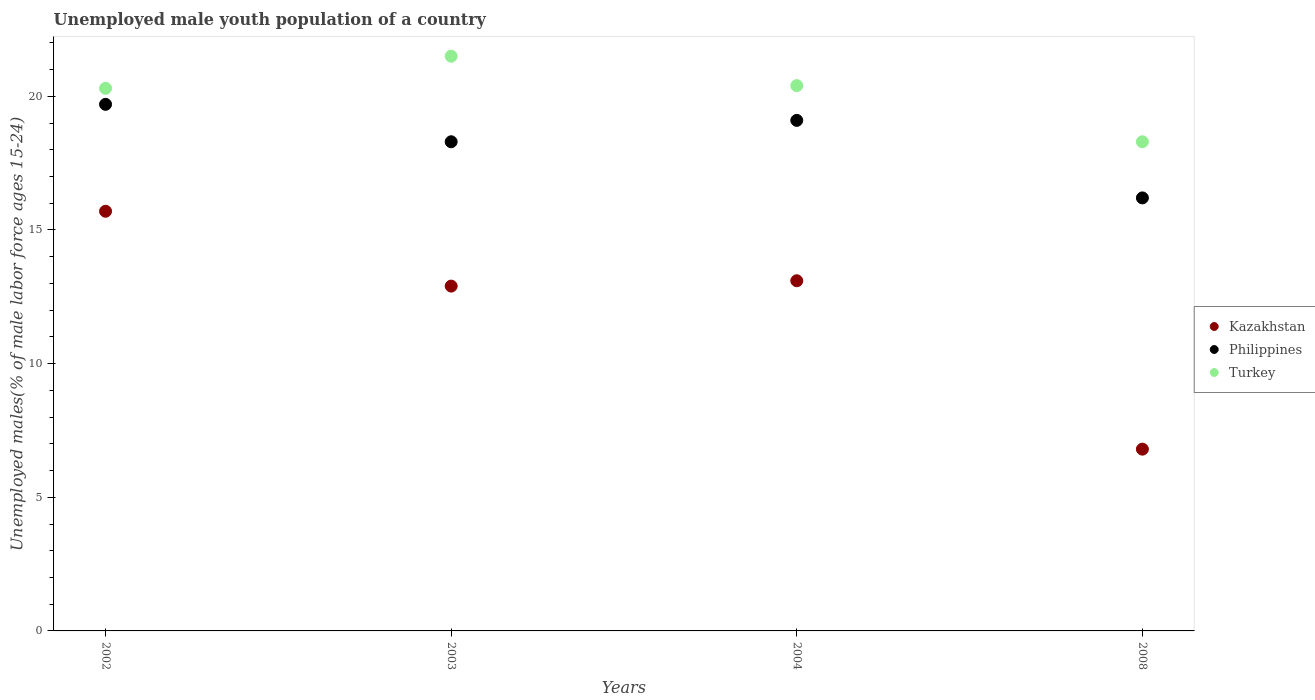What is the percentage of unemployed male youth population in Philippines in 2002?
Keep it short and to the point. 19.7. Across all years, what is the maximum percentage of unemployed male youth population in Kazakhstan?
Offer a terse response. 15.7. Across all years, what is the minimum percentage of unemployed male youth population in Philippines?
Ensure brevity in your answer.  16.2. In which year was the percentage of unemployed male youth population in Philippines minimum?
Offer a very short reply. 2008. What is the total percentage of unemployed male youth population in Turkey in the graph?
Ensure brevity in your answer.  80.5. What is the difference between the percentage of unemployed male youth population in Turkey in 2003 and that in 2008?
Provide a succinct answer. 3.2. What is the difference between the percentage of unemployed male youth population in Turkey in 2004 and the percentage of unemployed male youth population in Kazakhstan in 2003?
Give a very brief answer. 7.5. What is the average percentage of unemployed male youth population in Turkey per year?
Ensure brevity in your answer.  20.12. In the year 2008, what is the difference between the percentage of unemployed male youth population in Turkey and percentage of unemployed male youth population in Philippines?
Provide a short and direct response. 2.1. In how many years, is the percentage of unemployed male youth population in Philippines greater than 14 %?
Provide a succinct answer. 4. What is the ratio of the percentage of unemployed male youth population in Turkey in 2003 to that in 2008?
Give a very brief answer. 1.17. What is the difference between the highest and the second highest percentage of unemployed male youth population in Philippines?
Your answer should be compact. 0.6. What is the difference between the highest and the lowest percentage of unemployed male youth population in Turkey?
Make the answer very short. 3.2. In how many years, is the percentage of unemployed male youth population in Philippines greater than the average percentage of unemployed male youth population in Philippines taken over all years?
Your answer should be compact. 2. Is the sum of the percentage of unemployed male youth population in Philippines in 2002 and 2003 greater than the maximum percentage of unemployed male youth population in Kazakhstan across all years?
Provide a succinct answer. Yes. Does the percentage of unemployed male youth population in Philippines monotonically increase over the years?
Provide a succinct answer. No. Is the percentage of unemployed male youth population in Philippines strictly less than the percentage of unemployed male youth population in Kazakhstan over the years?
Keep it short and to the point. No. How many years are there in the graph?
Offer a terse response. 4. What is the difference between two consecutive major ticks on the Y-axis?
Your response must be concise. 5. Where does the legend appear in the graph?
Provide a succinct answer. Center right. What is the title of the graph?
Your response must be concise. Unemployed male youth population of a country. Does "Lithuania" appear as one of the legend labels in the graph?
Offer a very short reply. No. What is the label or title of the X-axis?
Offer a terse response. Years. What is the label or title of the Y-axis?
Make the answer very short. Unemployed males(% of male labor force ages 15-24). What is the Unemployed males(% of male labor force ages 15-24) of Kazakhstan in 2002?
Give a very brief answer. 15.7. What is the Unemployed males(% of male labor force ages 15-24) of Philippines in 2002?
Your answer should be very brief. 19.7. What is the Unemployed males(% of male labor force ages 15-24) of Turkey in 2002?
Ensure brevity in your answer.  20.3. What is the Unemployed males(% of male labor force ages 15-24) in Kazakhstan in 2003?
Offer a terse response. 12.9. What is the Unemployed males(% of male labor force ages 15-24) in Philippines in 2003?
Offer a very short reply. 18.3. What is the Unemployed males(% of male labor force ages 15-24) of Turkey in 2003?
Provide a succinct answer. 21.5. What is the Unemployed males(% of male labor force ages 15-24) in Kazakhstan in 2004?
Provide a short and direct response. 13.1. What is the Unemployed males(% of male labor force ages 15-24) of Philippines in 2004?
Keep it short and to the point. 19.1. What is the Unemployed males(% of male labor force ages 15-24) in Turkey in 2004?
Give a very brief answer. 20.4. What is the Unemployed males(% of male labor force ages 15-24) in Kazakhstan in 2008?
Keep it short and to the point. 6.8. What is the Unemployed males(% of male labor force ages 15-24) of Philippines in 2008?
Make the answer very short. 16.2. What is the Unemployed males(% of male labor force ages 15-24) in Turkey in 2008?
Your answer should be very brief. 18.3. Across all years, what is the maximum Unemployed males(% of male labor force ages 15-24) in Kazakhstan?
Make the answer very short. 15.7. Across all years, what is the maximum Unemployed males(% of male labor force ages 15-24) of Philippines?
Your response must be concise. 19.7. Across all years, what is the maximum Unemployed males(% of male labor force ages 15-24) in Turkey?
Give a very brief answer. 21.5. Across all years, what is the minimum Unemployed males(% of male labor force ages 15-24) in Kazakhstan?
Make the answer very short. 6.8. Across all years, what is the minimum Unemployed males(% of male labor force ages 15-24) in Philippines?
Your answer should be compact. 16.2. Across all years, what is the minimum Unemployed males(% of male labor force ages 15-24) of Turkey?
Keep it short and to the point. 18.3. What is the total Unemployed males(% of male labor force ages 15-24) of Kazakhstan in the graph?
Provide a short and direct response. 48.5. What is the total Unemployed males(% of male labor force ages 15-24) in Philippines in the graph?
Offer a very short reply. 73.3. What is the total Unemployed males(% of male labor force ages 15-24) of Turkey in the graph?
Make the answer very short. 80.5. What is the difference between the Unemployed males(% of male labor force ages 15-24) of Kazakhstan in 2002 and that in 2003?
Your answer should be compact. 2.8. What is the difference between the Unemployed males(% of male labor force ages 15-24) in Kazakhstan in 2002 and that in 2004?
Your response must be concise. 2.6. What is the difference between the Unemployed males(% of male labor force ages 15-24) in Kazakhstan in 2002 and that in 2008?
Keep it short and to the point. 8.9. What is the difference between the Unemployed males(% of male labor force ages 15-24) of Turkey in 2002 and that in 2008?
Your answer should be very brief. 2. What is the difference between the Unemployed males(% of male labor force ages 15-24) of Philippines in 2003 and that in 2004?
Your response must be concise. -0.8. What is the difference between the Unemployed males(% of male labor force ages 15-24) in Turkey in 2003 and that in 2004?
Ensure brevity in your answer.  1.1. What is the difference between the Unemployed males(% of male labor force ages 15-24) of Kazakhstan in 2003 and that in 2008?
Your answer should be very brief. 6.1. What is the difference between the Unemployed males(% of male labor force ages 15-24) in Philippines in 2003 and that in 2008?
Keep it short and to the point. 2.1. What is the difference between the Unemployed males(% of male labor force ages 15-24) of Kazakhstan in 2002 and the Unemployed males(% of male labor force ages 15-24) of Turkey in 2004?
Provide a short and direct response. -4.7. What is the difference between the Unemployed males(% of male labor force ages 15-24) of Kazakhstan in 2002 and the Unemployed males(% of male labor force ages 15-24) of Turkey in 2008?
Offer a terse response. -2.6. What is the difference between the Unemployed males(% of male labor force ages 15-24) of Philippines in 2002 and the Unemployed males(% of male labor force ages 15-24) of Turkey in 2008?
Offer a very short reply. 1.4. What is the difference between the Unemployed males(% of male labor force ages 15-24) in Kazakhstan in 2003 and the Unemployed males(% of male labor force ages 15-24) in Philippines in 2004?
Give a very brief answer. -6.2. What is the difference between the Unemployed males(% of male labor force ages 15-24) of Kazakhstan in 2003 and the Unemployed males(% of male labor force ages 15-24) of Turkey in 2004?
Your answer should be compact. -7.5. What is the difference between the Unemployed males(% of male labor force ages 15-24) of Philippines in 2003 and the Unemployed males(% of male labor force ages 15-24) of Turkey in 2004?
Give a very brief answer. -2.1. What is the difference between the Unemployed males(% of male labor force ages 15-24) in Kazakhstan in 2003 and the Unemployed males(% of male labor force ages 15-24) in Turkey in 2008?
Keep it short and to the point. -5.4. What is the difference between the Unemployed males(% of male labor force ages 15-24) of Kazakhstan in 2004 and the Unemployed males(% of male labor force ages 15-24) of Turkey in 2008?
Your response must be concise. -5.2. What is the average Unemployed males(% of male labor force ages 15-24) of Kazakhstan per year?
Your answer should be very brief. 12.12. What is the average Unemployed males(% of male labor force ages 15-24) of Philippines per year?
Ensure brevity in your answer.  18.32. What is the average Unemployed males(% of male labor force ages 15-24) of Turkey per year?
Your response must be concise. 20.12. In the year 2002, what is the difference between the Unemployed males(% of male labor force ages 15-24) in Kazakhstan and Unemployed males(% of male labor force ages 15-24) in Turkey?
Provide a short and direct response. -4.6. In the year 2003, what is the difference between the Unemployed males(% of male labor force ages 15-24) in Kazakhstan and Unemployed males(% of male labor force ages 15-24) in Turkey?
Your answer should be compact. -8.6. In the year 2004, what is the difference between the Unemployed males(% of male labor force ages 15-24) in Kazakhstan and Unemployed males(% of male labor force ages 15-24) in Philippines?
Your answer should be very brief. -6. In the year 2004, what is the difference between the Unemployed males(% of male labor force ages 15-24) in Kazakhstan and Unemployed males(% of male labor force ages 15-24) in Turkey?
Your answer should be compact. -7.3. In the year 2004, what is the difference between the Unemployed males(% of male labor force ages 15-24) in Philippines and Unemployed males(% of male labor force ages 15-24) in Turkey?
Your answer should be compact. -1.3. In the year 2008, what is the difference between the Unemployed males(% of male labor force ages 15-24) in Kazakhstan and Unemployed males(% of male labor force ages 15-24) in Philippines?
Your answer should be compact. -9.4. In the year 2008, what is the difference between the Unemployed males(% of male labor force ages 15-24) in Kazakhstan and Unemployed males(% of male labor force ages 15-24) in Turkey?
Provide a succinct answer. -11.5. What is the ratio of the Unemployed males(% of male labor force ages 15-24) in Kazakhstan in 2002 to that in 2003?
Your response must be concise. 1.22. What is the ratio of the Unemployed males(% of male labor force ages 15-24) in Philippines in 2002 to that in 2003?
Make the answer very short. 1.08. What is the ratio of the Unemployed males(% of male labor force ages 15-24) in Turkey in 2002 to that in 2003?
Ensure brevity in your answer.  0.94. What is the ratio of the Unemployed males(% of male labor force ages 15-24) in Kazakhstan in 2002 to that in 2004?
Offer a terse response. 1.2. What is the ratio of the Unemployed males(% of male labor force ages 15-24) in Philippines in 2002 to that in 2004?
Offer a terse response. 1.03. What is the ratio of the Unemployed males(% of male labor force ages 15-24) in Turkey in 2002 to that in 2004?
Provide a short and direct response. 1. What is the ratio of the Unemployed males(% of male labor force ages 15-24) of Kazakhstan in 2002 to that in 2008?
Offer a very short reply. 2.31. What is the ratio of the Unemployed males(% of male labor force ages 15-24) of Philippines in 2002 to that in 2008?
Make the answer very short. 1.22. What is the ratio of the Unemployed males(% of male labor force ages 15-24) of Turkey in 2002 to that in 2008?
Your answer should be compact. 1.11. What is the ratio of the Unemployed males(% of male labor force ages 15-24) of Kazakhstan in 2003 to that in 2004?
Give a very brief answer. 0.98. What is the ratio of the Unemployed males(% of male labor force ages 15-24) in Philippines in 2003 to that in 2004?
Provide a short and direct response. 0.96. What is the ratio of the Unemployed males(% of male labor force ages 15-24) of Turkey in 2003 to that in 2004?
Give a very brief answer. 1.05. What is the ratio of the Unemployed males(% of male labor force ages 15-24) of Kazakhstan in 2003 to that in 2008?
Your response must be concise. 1.9. What is the ratio of the Unemployed males(% of male labor force ages 15-24) in Philippines in 2003 to that in 2008?
Your answer should be compact. 1.13. What is the ratio of the Unemployed males(% of male labor force ages 15-24) of Turkey in 2003 to that in 2008?
Ensure brevity in your answer.  1.17. What is the ratio of the Unemployed males(% of male labor force ages 15-24) in Kazakhstan in 2004 to that in 2008?
Provide a short and direct response. 1.93. What is the ratio of the Unemployed males(% of male labor force ages 15-24) in Philippines in 2004 to that in 2008?
Keep it short and to the point. 1.18. What is the ratio of the Unemployed males(% of male labor force ages 15-24) of Turkey in 2004 to that in 2008?
Provide a short and direct response. 1.11. What is the difference between the highest and the second highest Unemployed males(% of male labor force ages 15-24) in Kazakhstan?
Provide a succinct answer. 2.6. What is the difference between the highest and the second highest Unemployed males(% of male labor force ages 15-24) in Philippines?
Offer a very short reply. 0.6. What is the difference between the highest and the second highest Unemployed males(% of male labor force ages 15-24) in Turkey?
Your response must be concise. 1.1. What is the difference between the highest and the lowest Unemployed males(% of male labor force ages 15-24) of Philippines?
Offer a very short reply. 3.5. What is the difference between the highest and the lowest Unemployed males(% of male labor force ages 15-24) in Turkey?
Your answer should be compact. 3.2. 